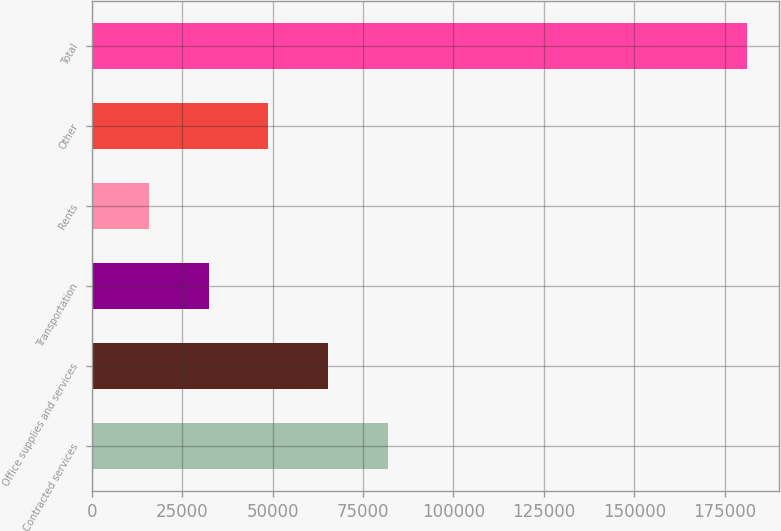Convert chart. <chart><loc_0><loc_0><loc_500><loc_500><bar_chart><fcel>Contracted services<fcel>Office supplies and services<fcel>Transportation<fcel>Rents<fcel>Other<fcel>Total<nl><fcel>81868.8<fcel>65338.1<fcel>32276.7<fcel>15746<fcel>48807.4<fcel>181053<nl></chart> 